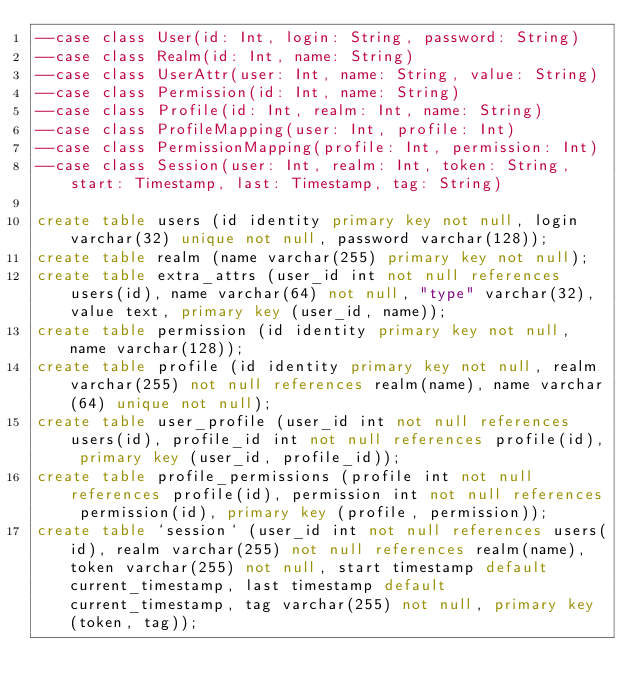Convert code to text. <code><loc_0><loc_0><loc_500><loc_500><_SQL_>--case class User(id: Int, login: String, password: String)
--case class Realm(id: Int, name: String)
--case class UserAttr(user: Int, name: String, value: String)
--case class Permission(id: Int, name: String)
--case class Profile(id: Int, realm: Int, name: String)
--case class ProfileMapping(user: Int, profile: Int)
--case class PermissionMapping(profile: Int, permission: Int)
--case class Session(user: Int, realm: Int, token: String, start: Timestamp, last: Timestamp, tag: String)

create table users (id identity primary key not null, login varchar(32) unique not null, password varchar(128));
create table realm (name varchar(255) primary key not null);
create table extra_attrs (user_id int not null references users(id), name varchar(64) not null, "type" varchar(32), value text, primary key (user_id, name));
create table permission (id identity primary key not null, name varchar(128));
create table profile (id identity primary key not null, realm varchar(255) not null references realm(name), name varchar(64) unique not null);
create table user_profile (user_id int not null references users(id), profile_id int not null references profile(id), primary key (user_id, profile_id));
create table profile_permissions (profile int not null references profile(id), permission int not null references permission(id), primary key (profile, permission));
create table `session` (user_id int not null references users(id), realm varchar(255) not null references realm(name), token varchar(255) not null, start timestamp default current_timestamp, last timestamp default current_timestamp, tag varchar(255) not null, primary key (token, tag));
</code> 